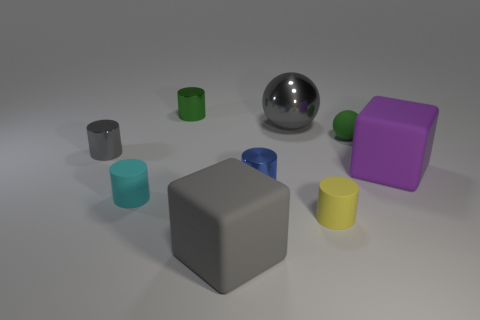Are there any other things that are the same shape as the big gray shiny thing?
Keep it short and to the point. Yes. Does the large rubber object right of the yellow cylinder have the same color as the shiny object left of the small green shiny cylinder?
Your answer should be compact. No. Are any purple rubber blocks visible?
Keep it short and to the point. Yes. What material is the large block that is the same color as the metallic ball?
Keep it short and to the point. Rubber. There is a gray object in front of the rubber object that is to the left of the metal thing behind the big shiny sphere; how big is it?
Offer a terse response. Large. There is a small yellow object; is its shape the same as the large thing on the left side of the tiny blue object?
Offer a terse response. No. Is there a rubber cylinder that has the same color as the tiny sphere?
Ensure brevity in your answer.  No. How many balls are purple rubber objects or tiny green metal objects?
Your response must be concise. 0. Are there any purple objects of the same shape as the tiny green rubber thing?
Provide a short and direct response. No. How many other objects are the same color as the large sphere?
Provide a short and direct response. 2. 